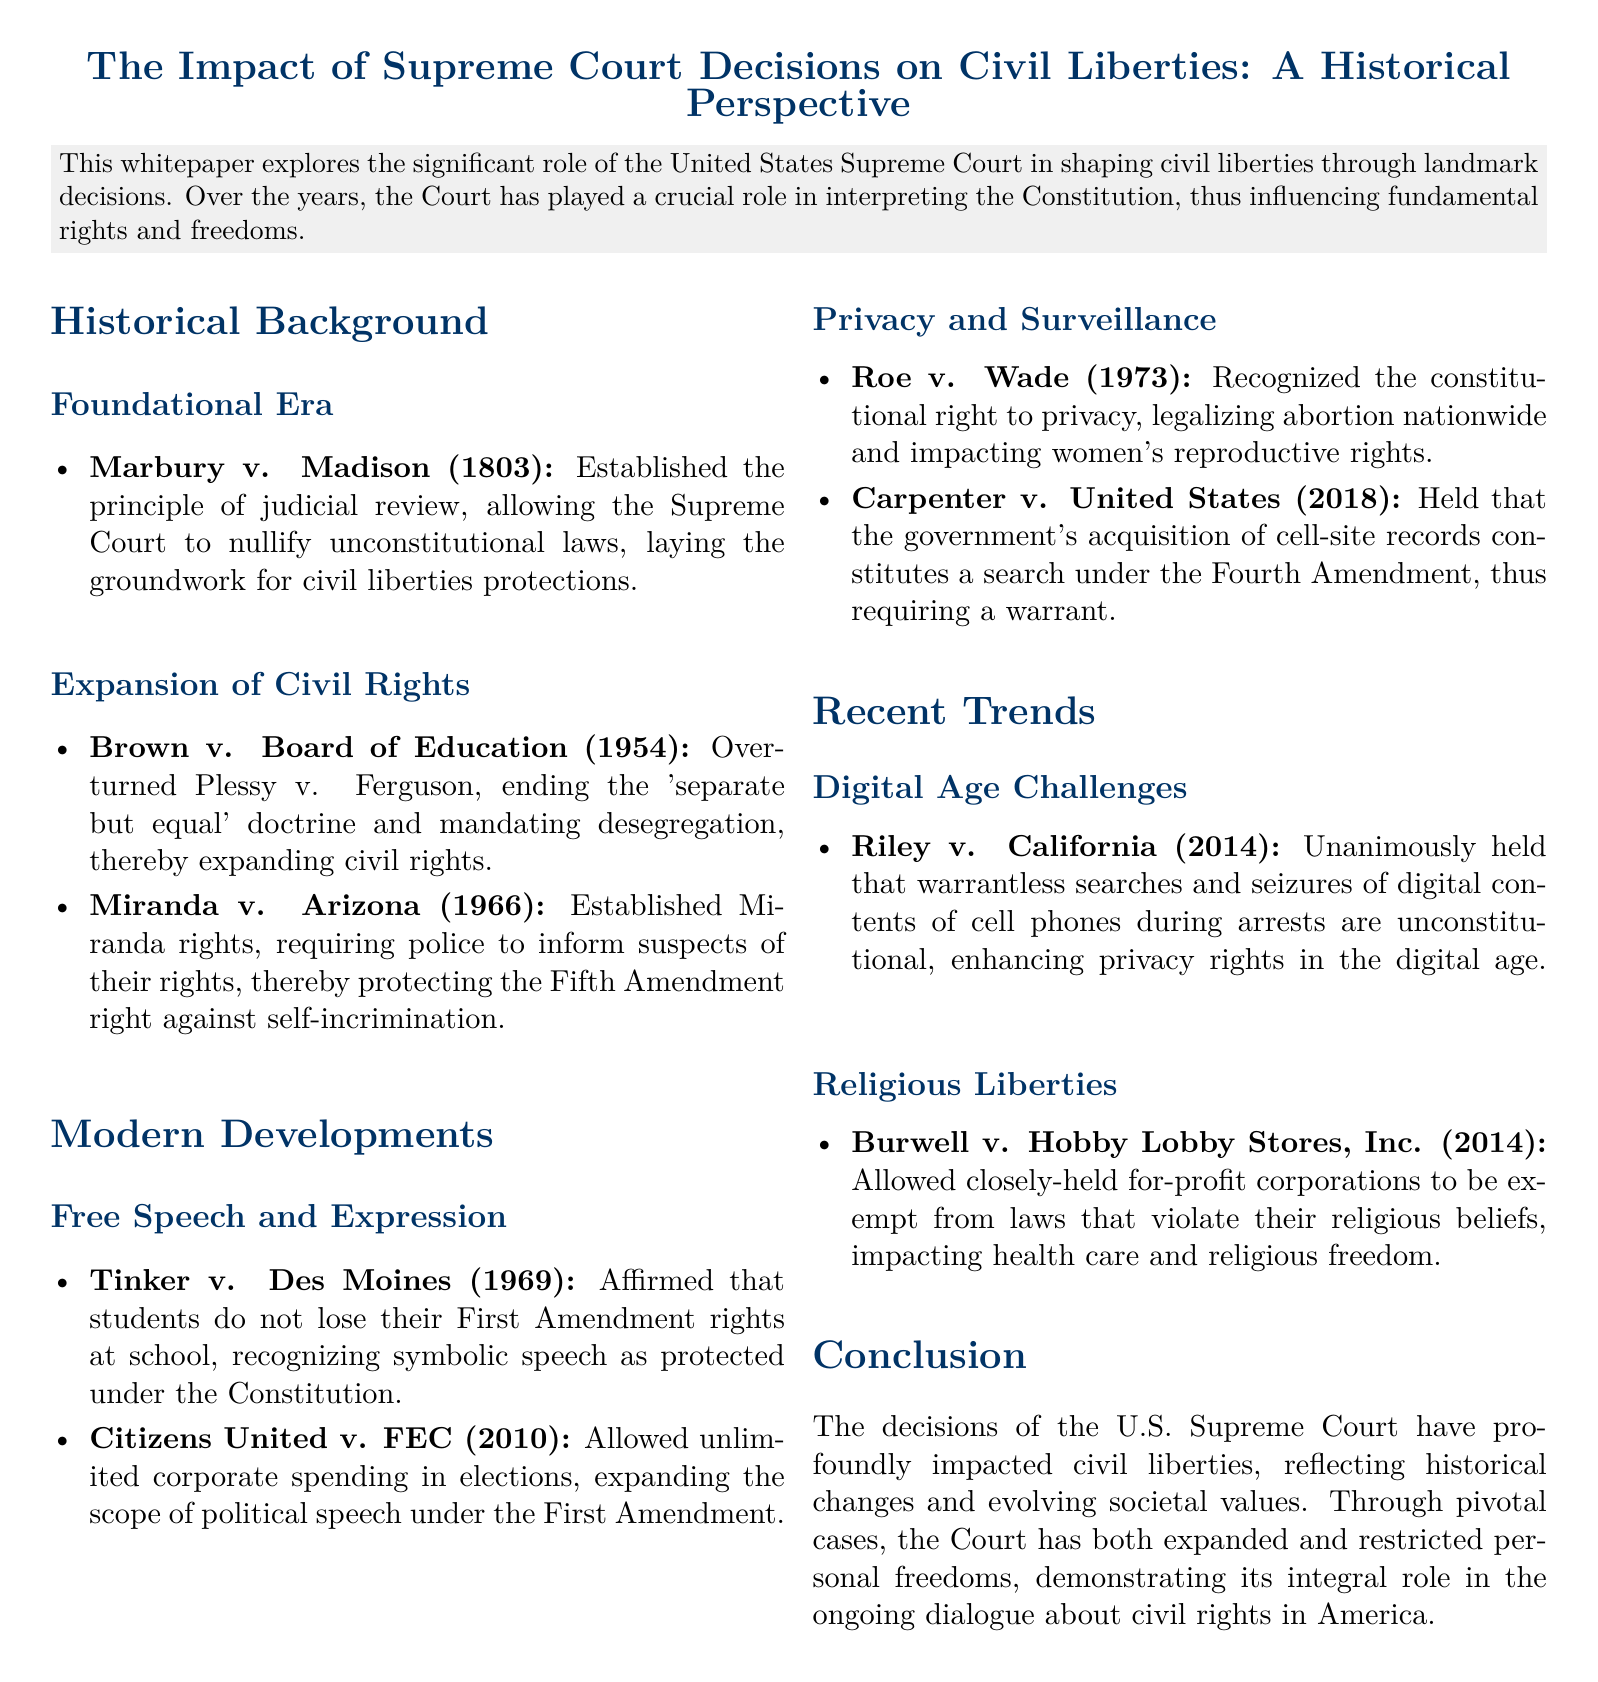What landmark decision established judicial review? The document states that Marbury v. Madison (1803) established judicial review, allowing the Supreme Court to nullify unconstitutional laws.
Answer: Marbury v. Madison (1803) What case overturned the 'separate but equal' doctrine? According to the document, Brown v. Board of Education (1954) ended the 'separate but equal' doctrine and mandated desegregation.
Answer: Brown v. Board of Education (1954) In which year was Miranda rights established? The document indicates that Miranda v. Arizona established Miranda rights in 1966, requiring police to inform suspects of their rights.
Answer: 1966 Which case recognized a constitutional right to privacy? The document mentions Roe v. Wade (1973) as recognizing the constitutional right to privacy and legalizing abortion nationwide.
Answer: Roe v. Wade (1973) What is the significance of Riley v. California? The document notes that Riley v. California (2014) held that warrantless searches of digital contents of cell phones are unconstitutional, thereby enhancing privacy rights.
Answer: Warrantless searches of digital contents of cell phones What does Burwell v. Hobby Lobby Stores, Inc. permit? The document explains that Burwell v. Hobby Lobby Stores, Inc. allows closely-held for-profit corporations to be exempt from laws that violate their religious beliefs.
Answer: Exempt from laws that violate religious beliefs How did the Supreme Court's decisions reflect societal changes? The document discusses how the decisions of the U.S. Supreme Court have impacted civil liberties, demonstrating its role in the ongoing dialogue about civil rights in America.
Answer: Impacted civil liberties What area of law did the whitepaper primarily focus on? The title indicates that the whitepaper explores the impact of Supreme Court decisions on civil liberties from a historical perspective.
Answer: Civil liberties 